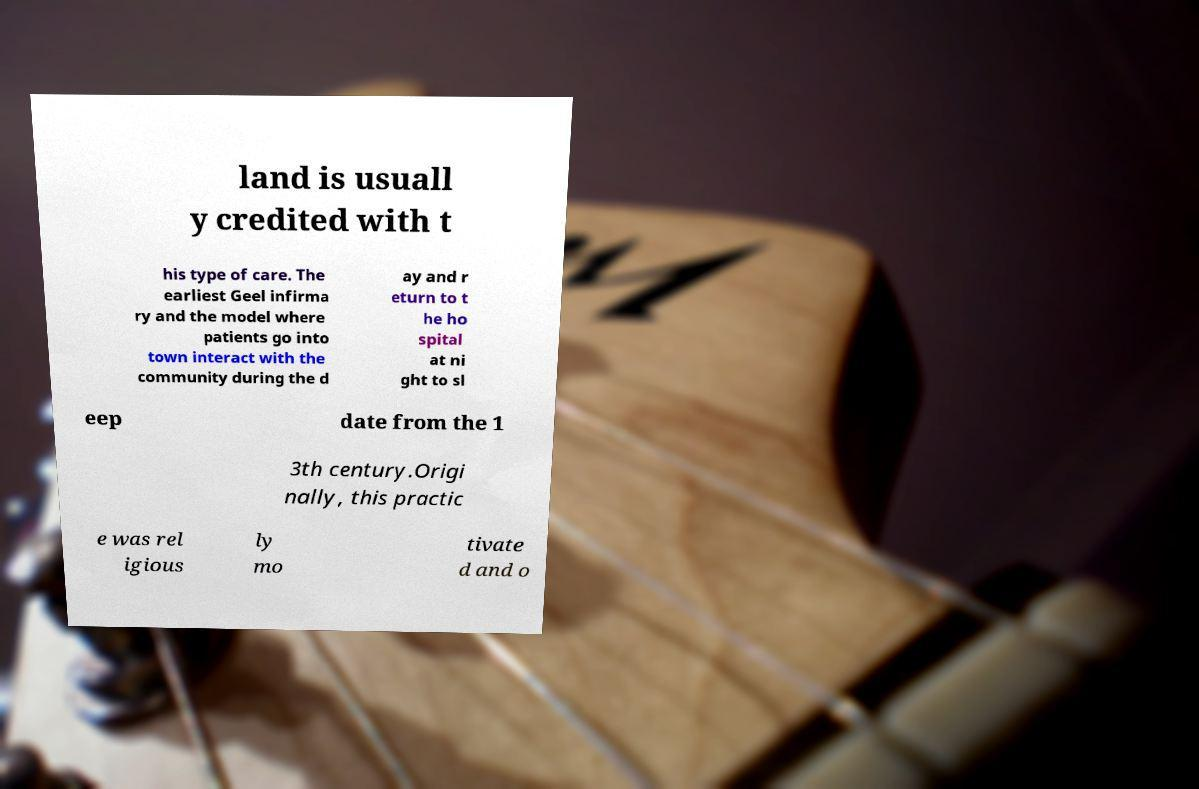Please read and relay the text visible in this image. What does it say? land is usuall y credited with t his type of care. The earliest Geel infirma ry and the model where patients go into town interact with the community during the d ay and r eturn to t he ho spital at ni ght to sl eep date from the 1 3th century.Origi nally, this practic e was rel igious ly mo tivate d and o 